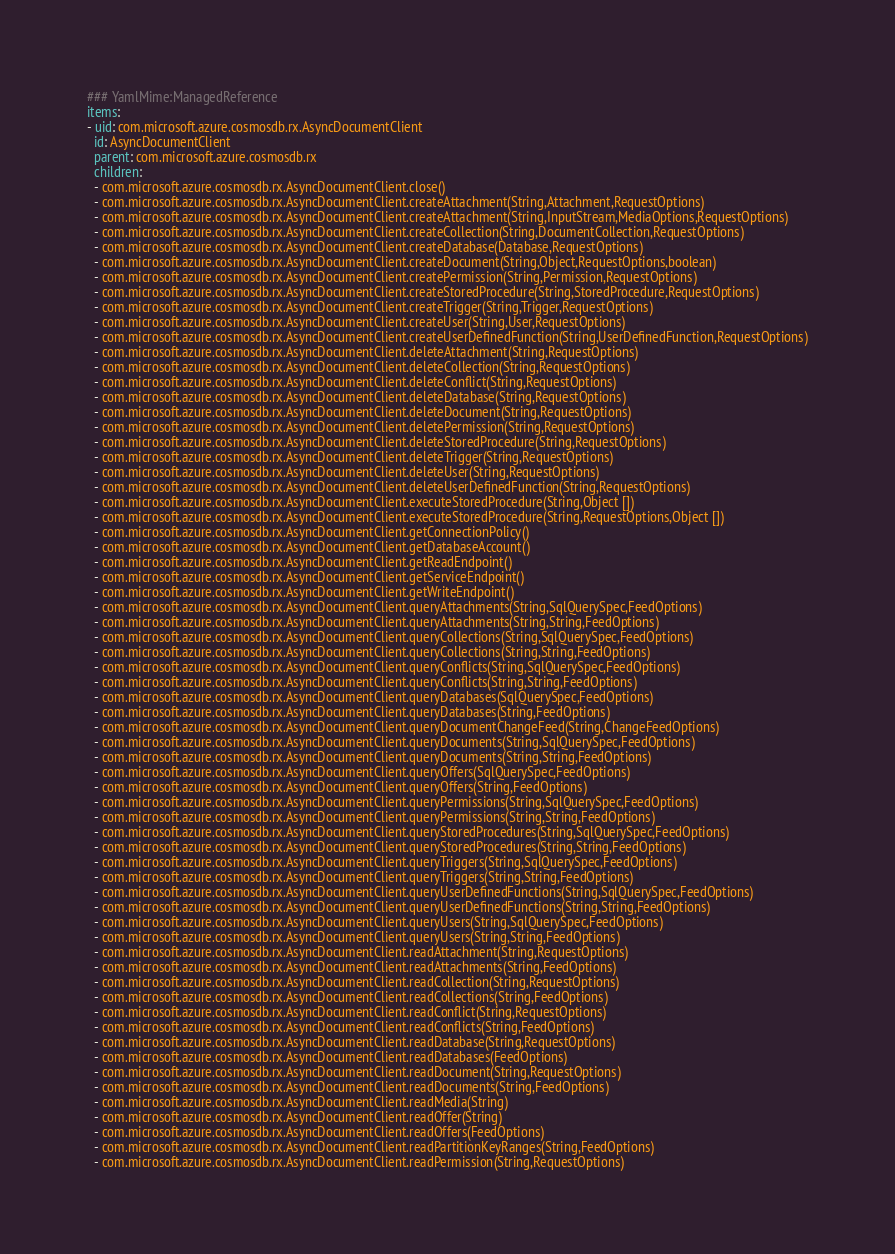<code> <loc_0><loc_0><loc_500><loc_500><_YAML_>### YamlMime:ManagedReference
items:
- uid: com.microsoft.azure.cosmosdb.rx.AsyncDocumentClient
  id: AsyncDocumentClient
  parent: com.microsoft.azure.cosmosdb.rx
  children:
  - com.microsoft.azure.cosmosdb.rx.AsyncDocumentClient.close()
  - com.microsoft.azure.cosmosdb.rx.AsyncDocumentClient.createAttachment(String,Attachment,RequestOptions)
  - com.microsoft.azure.cosmosdb.rx.AsyncDocumentClient.createAttachment(String,InputStream,MediaOptions,RequestOptions)
  - com.microsoft.azure.cosmosdb.rx.AsyncDocumentClient.createCollection(String,DocumentCollection,RequestOptions)
  - com.microsoft.azure.cosmosdb.rx.AsyncDocumentClient.createDatabase(Database,RequestOptions)
  - com.microsoft.azure.cosmosdb.rx.AsyncDocumentClient.createDocument(String,Object,RequestOptions,boolean)
  - com.microsoft.azure.cosmosdb.rx.AsyncDocumentClient.createPermission(String,Permission,RequestOptions)
  - com.microsoft.azure.cosmosdb.rx.AsyncDocumentClient.createStoredProcedure(String,StoredProcedure,RequestOptions)
  - com.microsoft.azure.cosmosdb.rx.AsyncDocumentClient.createTrigger(String,Trigger,RequestOptions)
  - com.microsoft.azure.cosmosdb.rx.AsyncDocumentClient.createUser(String,User,RequestOptions)
  - com.microsoft.azure.cosmosdb.rx.AsyncDocumentClient.createUserDefinedFunction(String,UserDefinedFunction,RequestOptions)
  - com.microsoft.azure.cosmosdb.rx.AsyncDocumentClient.deleteAttachment(String,RequestOptions)
  - com.microsoft.azure.cosmosdb.rx.AsyncDocumentClient.deleteCollection(String,RequestOptions)
  - com.microsoft.azure.cosmosdb.rx.AsyncDocumentClient.deleteConflict(String,RequestOptions)
  - com.microsoft.azure.cosmosdb.rx.AsyncDocumentClient.deleteDatabase(String,RequestOptions)
  - com.microsoft.azure.cosmosdb.rx.AsyncDocumentClient.deleteDocument(String,RequestOptions)
  - com.microsoft.azure.cosmosdb.rx.AsyncDocumentClient.deletePermission(String,RequestOptions)
  - com.microsoft.azure.cosmosdb.rx.AsyncDocumentClient.deleteStoredProcedure(String,RequestOptions)
  - com.microsoft.azure.cosmosdb.rx.AsyncDocumentClient.deleteTrigger(String,RequestOptions)
  - com.microsoft.azure.cosmosdb.rx.AsyncDocumentClient.deleteUser(String,RequestOptions)
  - com.microsoft.azure.cosmosdb.rx.AsyncDocumentClient.deleteUserDefinedFunction(String,RequestOptions)
  - com.microsoft.azure.cosmosdb.rx.AsyncDocumentClient.executeStoredProcedure(String,Object [])
  - com.microsoft.azure.cosmosdb.rx.AsyncDocumentClient.executeStoredProcedure(String,RequestOptions,Object [])
  - com.microsoft.azure.cosmosdb.rx.AsyncDocumentClient.getConnectionPolicy()
  - com.microsoft.azure.cosmosdb.rx.AsyncDocumentClient.getDatabaseAccount()
  - com.microsoft.azure.cosmosdb.rx.AsyncDocumentClient.getReadEndpoint()
  - com.microsoft.azure.cosmosdb.rx.AsyncDocumentClient.getServiceEndpoint()
  - com.microsoft.azure.cosmosdb.rx.AsyncDocumentClient.getWriteEndpoint()
  - com.microsoft.azure.cosmosdb.rx.AsyncDocumentClient.queryAttachments(String,SqlQuerySpec,FeedOptions)
  - com.microsoft.azure.cosmosdb.rx.AsyncDocumentClient.queryAttachments(String,String,FeedOptions)
  - com.microsoft.azure.cosmosdb.rx.AsyncDocumentClient.queryCollections(String,SqlQuerySpec,FeedOptions)
  - com.microsoft.azure.cosmosdb.rx.AsyncDocumentClient.queryCollections(String,String,FeedOptions)
  - com.microsoft.azure.cosmosdb.rx.AsyncDocumentClient.queryConflicts(String,SqlQuerySpec,FeedOptions)
  - com.microsoft.azure.cosmosdb.rx.AsyncDocumentClient.queryConflicts(String,String,FeedOptions)
  - com.microsoft.azure.cosmosdb.rx.AsyncDocumentClient.queryDatabases(SqlQuerySpec,FeedOptions)
  - com.microsoft.azure.cosmosdb.rx.AsyncDocumentClient.queryDatabases(String,FeedOptions)
  - com.microsoft.azure.cosmosdb.rx.AsyncDocumentClient.queryDocumentChangeFeed(String,ChangeFeedOptions)
  - com.microsoft.azure.cosmosdb.rx.AsyncDocumentClient.queryDocuments(String,SqlQuerySpec,FeedOptions)
  - com.microsoft.azure.cosmosdb.rx.AsyncDocumentClient.queryDocuments(String,String,FeedOptions)
  - com.microsoft.azure.cosmosdb.rx.AsyncDocumentClient.queryOffers(SqlQuerySpec,FeedOptions)
  - com.microsoft.azure.cosmosdb.rx.AsyncDocumentClient.queryOffers(String,FeedOptions)
  - com.microsoft.azure.cosmosdb.rx.AsyncDocumentClient.queryPermissions(String,SqlQuerySpec,FeedOptions)
  - com.microsoft.azure.cosmosdb.rx.AsyncDocumentClient.queryPermissions(String,String,FeedOptions)
  - com.microsoft.azure.cosmosdb.rx.AsyncDocumentClient.queryStoredProcedures(String,SqlQuerySpec,FeedOptions)
  - com.microsoft.azure.cosmosdb.rx.AsyncDocumentClient.queryStoredProcedures(String,String,FeedOptions)
  - com.microsoft.azure.cosmosdb.rx.AsyncDocumentClient.queryTriggers(String,SqlQuerySpec,FeedOptions)
  - com.microsoft.azure.cosmosdb.rx.AsyncDocumentClient.queryTriggers(String,String,FeedOptions)
  - com.microsoft.azure.cosmosdb.rx.AsyncDocumentClient.queryUserDefinedFunctions(String,SqlQuerySpec,FeedOptions)
  - com.microsoft.azure.cosmosdb.rx.AsyncDocumentClient.queryUserDefinedFunctions(String,String,FeedOptions)
  - com.microsoft.azure.cosmosdb.rx.AsyncDocumentClient.queryUsers(String,SqlQuerySpec,FeedOptions)
  - com.microsoft.azure.cosmosdb.rx.AsyncDocumentClient.queryUsers(String,String,FeedOptions)
  - com.microsoft.azure.cosmosdb.rx.AsyncDocumentClient.readAttachment(String,RequestOptions)
  - com.microsoft.azure.cosmosdb.rx.AsyncDocumentClient.readAttachments(String,FeedOptions)
  - com.microsoft.azure.cosmosdb.rx.AsyncDocumentClient.readCollection(String,RequestOptions)
  - com.microsoft.azure.cosmosdb.rx.AsyncDocumentClient.readCollections(String,FeedOptions)
  - com.microsoft.azure.cosmosdb.rx.AsyncDocumentClient.readConflict(String,RequestOptions)
  - com.microsoft.azure.cosmosdb.rx.AsyncDocumentClient.readConflicts(String,FeedOptions)
  - com.microsoft.azure.cosmosdb.rx.AsyncDocumentClient.readDatabase(String,RequestOptions)
  - com.microsoft.azure.cosmosdb.rx.AsyncDocumentClient.readDatabases(FeedOptions)
  - com.microsoft.azure.cosmosdb.rx.AsyncDocumentClient.readDocument(String,RequestOptions)
  - com.microsoft.azure.cosmosdb.rx.AsyncDocumentClient.readDocuments(String,FeedOptions)
  - com.microsoft.azure.cosmosdb.rx.AsyncDocumentClient.readMedia(String)
  - com.microsoft.azure.cosmosdb.rx.AsyncDocumentClient.readOffer(String)
  - com.microsoft.azure.cosmosdb.rx.AsyncDocumentClient.readOffers(FeedOptions)
  - com.microsoft.azure.cosmosdb.rx.AsyncDocumentClient.readPartitionKeyRanges(String,FeedOptions)
  - com.microsoft.azure.cosmosdb.rx.AsyncDocumentClient.readPermission(String,RequestOptions)</code> 